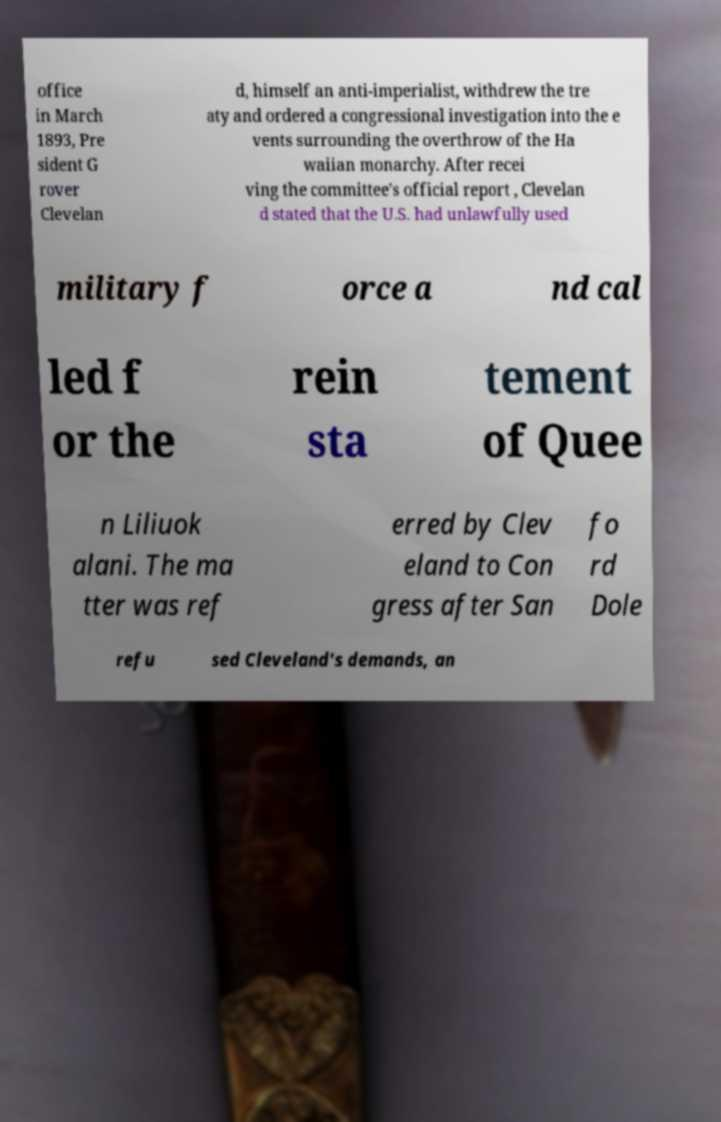Could you assist in decoding the text presented in this image and type it out clearly? office in March 1893, Pre sident G rover Clevelan d, himself an anti-imperialist, withdrew the tre aty and ordered a congressional investigation into the e vents surrounding the overthrow of the Ha waiian monarchy. After recei ving the committee's official report , Clevelan d stated that the U.S. had unlawfully used military f orce a nd cal led f or the rein sta tement of Quee n Liliuok alani. The ma tter was ref erred by Clev eland to Con gress after San fo rd Dole refu sed Cleveland's demands, an 